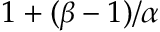<formula> <loc_0><loc_0><loc_500><loc_500>1 + ( \beta - 1 ) / \alpha</formula> 